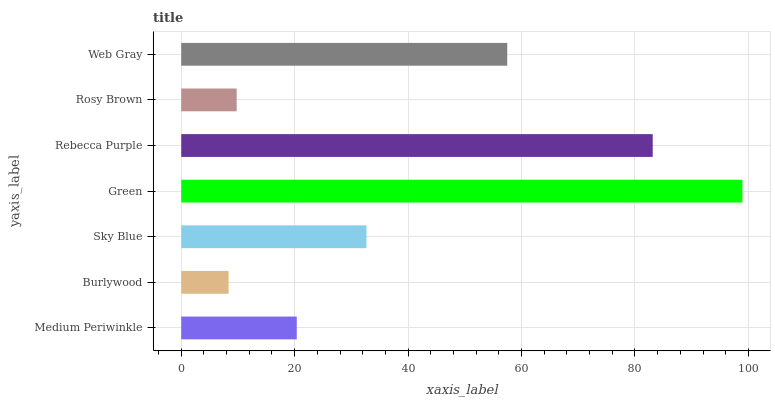Is Burlywood the minimum?
Answer yes or no. Yes. Is Green the maximum?
Answer yes or no. Yes. Is Sky Blue the minimum?
Answer yes or no. No. Is Sky Blue the maximum?
Answer yes or no. No. Is Sky Blue greater than Burlywood?
Answer yes or no. Yes. Is Burlywood less than Sky Blue?
Answer yes or no. Yes. Is Burlywood greater than Sky Blue?
Answer yes or no. No. Is Sky Blue less than Burlywood?
Answer yes or no. No. Is Sky Blue the high median?
Answer yes or no. Yes. Is Sky Blue the low median?
Answer yes or no. Yes. Is Green the high median?
Answer yes or no. No. Is Burlywood the low median?
Answer yes or no. No. 